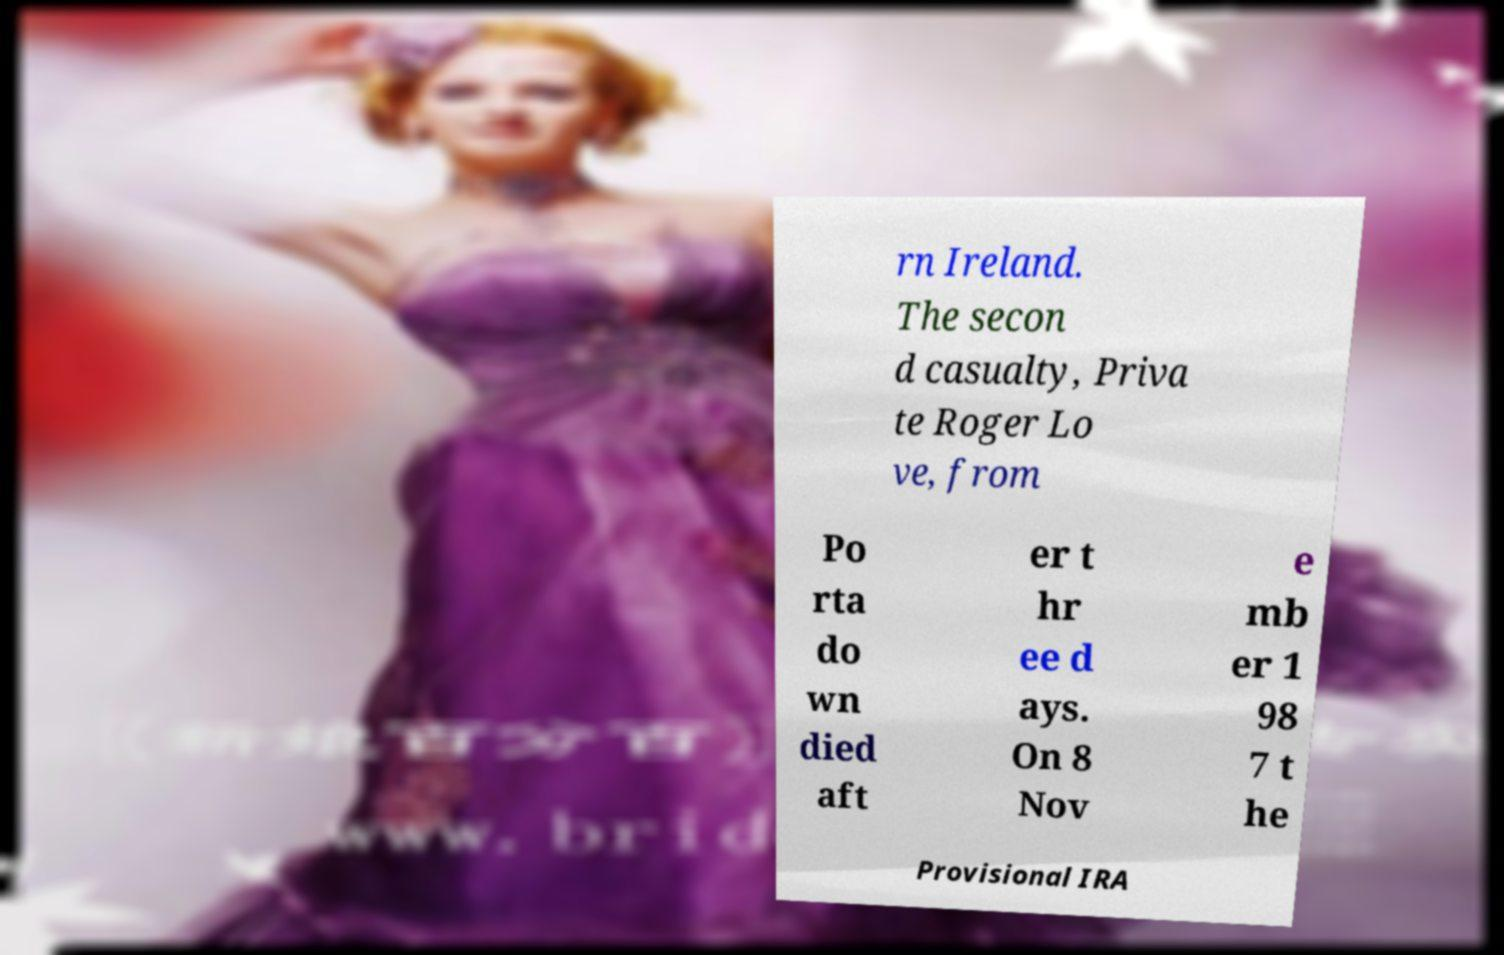Can you read and provide the text displayed in the image?This photo seems to have some interesting text. Can you extract and type it out for me? rn Ireland. The secon d casualty, Priva te Roger Lo ve, from Po rta do wn died aft er t hr ee d ays. On 8 Nov e mb er 1 98 7 t he Provisional IRA 